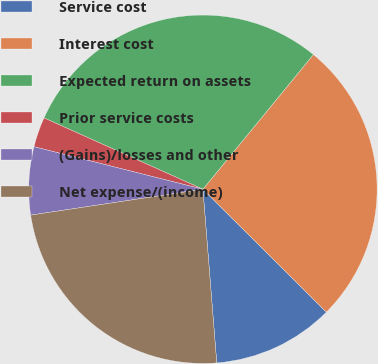<chart> <loc_0><loc_0><loc_500><loc_500><pie_chart><fcel>Service cost<fcel>Interest cost<fcel>Expected return on assets<fcel>Prior service costs<fcel>(Gains)/losses and other<fcel>Net expense/(income)<nl><fcel>11.27%<fcel>26.53%<fcel>29.22%<fcel>2.79%<fcel>6.3%<fcel>23.89%<nl></chart> 